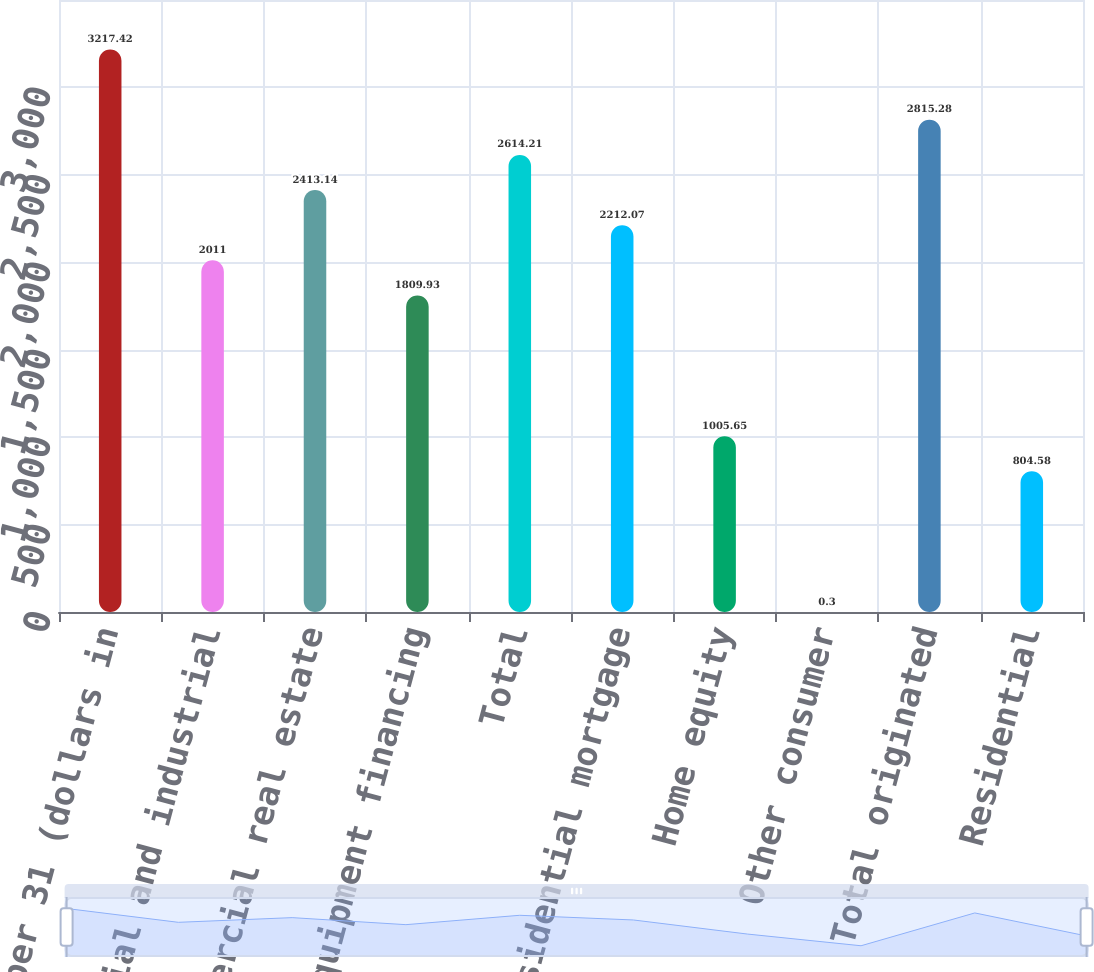Convert chart to OTSL. <chart><loc_0><loc_0><loc_500><loc_500><bar_chart><fcel>As of December 31 (dollars in<fcel>Commercial and industrial<fcel>Commercial real estate<fcel>Equipment financing<fcel>Total<fcel>Residential mortgage<fcel>Home equity<fcel>Other consumer<fcel>Total originated<fcel>Residential<nl><fcel>3217.42<fcel>2011<fcel>2413.14<fcel>1809.93<fcel>2614.21<fcel>2212.07<fcel>1005.65<fcel>0.3<fcel>2815.28<fcel>804.58<nl></chart> 